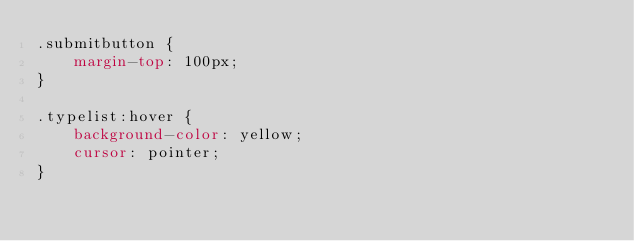<code> <loc_0><loc_0><loc_500><loc_500><_CSS_>.submitbutton {
    margin-top: 100px;
}

.typelist:hover {
    background-color: yellow;
    cursor: pointer;
}</code> 